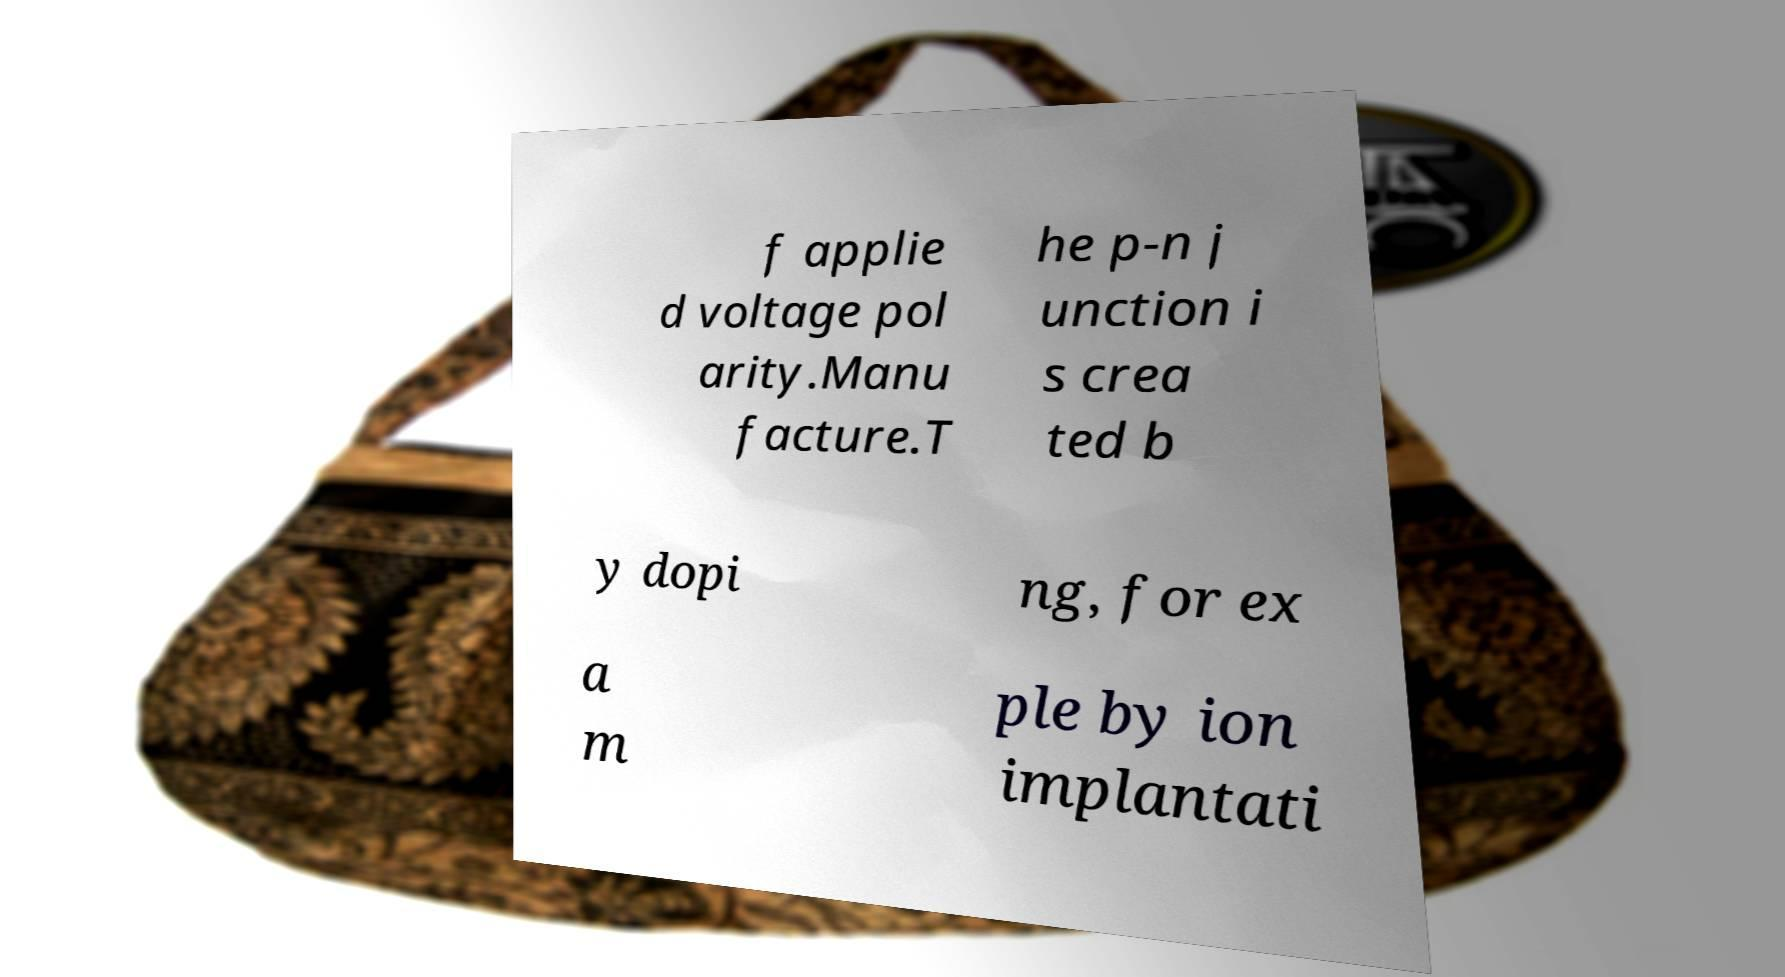For documentation purposes, I need the text within this image transcribed. Could you provide that? f applie d voltage pol arity.Manu facture.T he p-n j unction i s crea ted b y dopi ng, for ex a m ple by ion implantati 